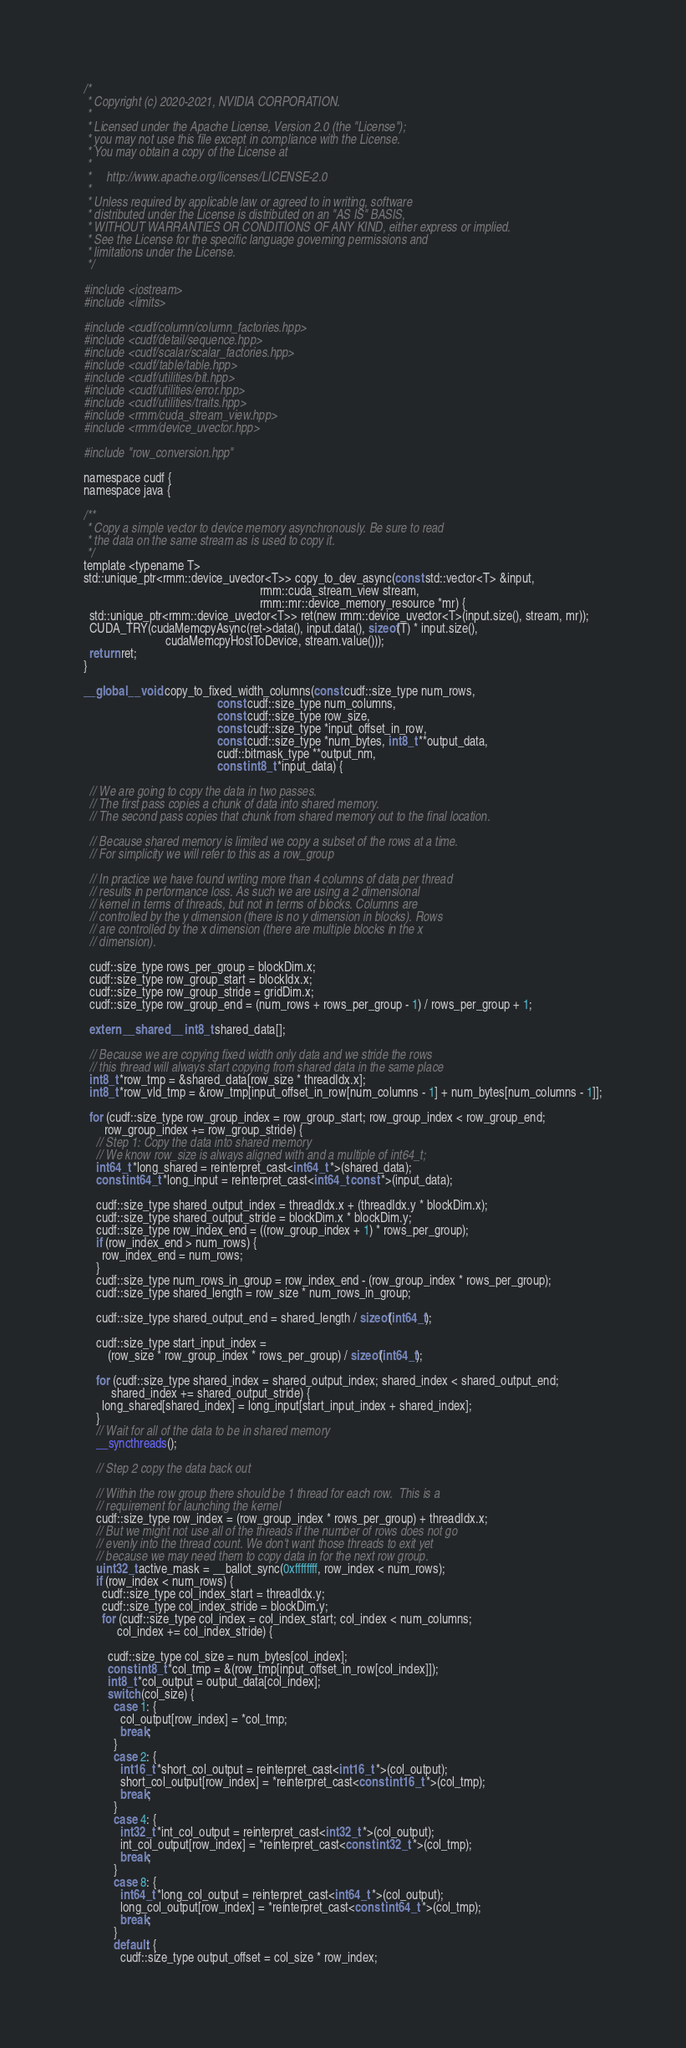Convert code to text. <code><loc_0><loc_0><loc_500><loc_500><_Cuda_>/*
 * Copyright (c) 2020-2021, NVIDIA CORPORATION.
 *
 * Licensed under the Apache License, Version 2.0 (the "License");
 * you may not use this file except in compliance with the License.
 * You may obtain a copy of the License at
 *
 *     http://www.apache.org/licenses/LICENSE-2.0
 *
 * Unless required by applicable law or agreed to in writing, software
 * distributed under the License is distributed on an "AS IS" BASIS,
 * WITHOUT WARRANTIES OR CONDITIONS OF ANY KIND, either express or implied.
 * See the License for the specific language governing permissions and
 * limitations under the License.
 */

#include <iostream>
#include <limits>

#include <cudf/column/column_factories.hpp>
#include <cudf/detail/sequence.hpp>
#include <cudf/scalar/scalar_factories.hpp>
#include <cudf/table/table.hpp>
#include <cudf/utilities/bit.hpp>
#include <cudf/utilities/error.hpp>
#include <cudf/utilities/traits.hpp>
#include <rmm/cuda_stream_view.hpp>
#include <rmm/device_uvector.hpp>

#include "row_conversion.hpp"

namespace cudf {
namespace java {

/**
 * Copy a simple vector to device memory asynchronously. Be sure to read
 * the data on the same stream as is used to copy it.
 */
template <typename T>
std::unique_ptr<rmm::device_uvector<T>> copy_to_dev_async(const std::vector<T> &input,
                                                          rmm::cuda_stream_view stream,
                                                          rmm::mr::device_memory_resource *mr) {
  std::unique_ptr<rmm::device_uvector<T>> ret(new rmm::device_uvector<T>(input.size(), stream, mr));
  CUDA_TRY(cudaMemcpyAsync(ret->data(), input.data(), sizeof(T) * input.size(),
                           cudaMemcpyHostToDevice, stream.value()));
  return ret;
}

__global__ void copy_to_fixed_width_columns(const cudf::size_type num_rows,
                                            const cudf::size_type num_columns,
                                            const cudf::size_type row_size,
                                            const cudf::size_type *input_offset_in_row,
                                            const cudf::size_type *num_bytes, int8_t **output_data,
                                            cudf::bitmask_type **output_nm,
                                            const int8_t *input_data) {

  // We are going to copy the data in two passes.
  // The first pass copies a chunk of data into shared memory.
  // The second pass copies that chunk from shared memory out to the final location.

  // Because shared memory is limited we copy a subset of the rows at a time.
  // For simplicity we will refer to this as a row_group

  // In practice we have found writing more than 4 columns of data per thread
  // results in performance loss. As such we are using a 2 dimensional
  // kernel in terms of threads, but not in terms of blocks. Columns are
  // controlled by the y dimension (there is no y dimension in blocks). Rows
  // are controlled by the x dimension (there are multiple blocks in the x
  // dimension).

  cudf::size_type rows_per_group = blockDim.x;
  cudf::size_type row_group_start = blockIdx.x;
  cudf::size_type row_group_stride = gridDim.x;
  cudf::size_type row_group_end = (num_rows + rows_per_group - 1) / rows_per_group + 1;

  extern __shared__ int8_t shared_data[];

  // Because we are copying fixed width only data and we stride the rows
  // this thread will always start copying from shared data in the same place
  int8_t *row_tmp = &shared_data[row_size * threadIdx.x];
  int8_t *row_vld_tmp = &row_tmp[input_offset_in_row[num_columns - 1] + num_bytes[num_columns - 1]];

  for (cudf::size_type row_group_index = row_group_start; row_group_index < row_group_end;
       row_group_index += row_group_stride) {
    // Step 1: Copy the data into shared memory
    // We know row_size is always aligned with and a multiple of int64_t;
    int64_t *long_shared = reinterpret_cast<int64_t *>(shared_data);
    const int64_t *long_input = reinterpret_cast<int64_t const *>(input_data);

    cudf::size_type shared_output_index = threadIdx.x + (threadIdx.y * blockDim.x);
    cudf::size_type shared_output_stride = blockDim.x * blockDim.y;
    cudf::size_type row_index_end = ((row_group_index + 1) * rows_per_group);
    if (row_index_end > num_rows) {
      row_index_end = num_rows;
    }
    cudf::size_type num_rows_in_group = row_index_end - (row_group_index * rows_per_group);
    cudf::size_type shared_length = row_size * num_rows_in_group;

    cudf::size_type shared_output_end = shared_length / sizeof(int64_t);

    cudf::size_type start_input_index =
        (row_size * row_group_index * rows_per_group) / sizeof(int64_t);

    for (cudf::size_type shared_index = shared_output_index; shared_index < shared_output_end;
         shared_index += shared_output_stride) {
      long_shared[shared_index] = long_input[start_input_index + shared_index];
    }
    // Wait for all of the data to be in shared memory
    __syncthreads();

    // Step 2 copy the data back out

    // Within the row group there should be 1 thread for each row.  This is a
    // requirement for launching the kernel
    cudf::size_type row_index = (row_group_index * rows_per_group) + threadIdx.x;
    // But we might not use all of the threads if the number of rows does not go
    // evenly into the thread count. We don't want those threads to exit yet
    // because we may need them to copy data in for the next row group.
    uint32_t active_mask = __ballot_sync(0xffffffff, row_index < num_rows);
    if (row_index < num_rows) {
      cudf::size_type col_index_start = threadIdx.y;
      cudf::size_type col_index_stride = blockDim.y;
      for (cudf::size_type col_index = col_index_start; col_index < num_columns;
           col_index += col_index_stride) {

        cudf::size_type col_size = num_bytes[col_index];
        const int8_t *col_tmp = &(row_tmp[input_offset_in_row[col_index]]);
        int8_t *col_output = output_data[col_index];
        switch (col_size) {
          case 1: {
            col_output[row_index] = *col_tmp;
            break;
          }
          case 2: {
            int16_t *short_col_output = reinterpret_cast<int16_t *>(col_output);
            short_col_output[row_index] = *reinterpret_cast<const int16_t *>(col_tmp);
            break;
          }
          case 4: {
            int32_t *int_col_output = reinterpret_cast<int32_t *>(col_output);
            int_col_output[row_index] = *reinterpret_cast<const int32_t *>(col_tmp);
            break;
          }
          case 8: {
            int64_t *long_col_output = reinterpret_cast<int64_t *>(col_output);
            long_col_output[row_index] = *reinterpret_cast<const int64_t *>(col_tmp);
            break;
          }
          default: {
            cudf::size_type output_offset = col_size * row_index;</code> 